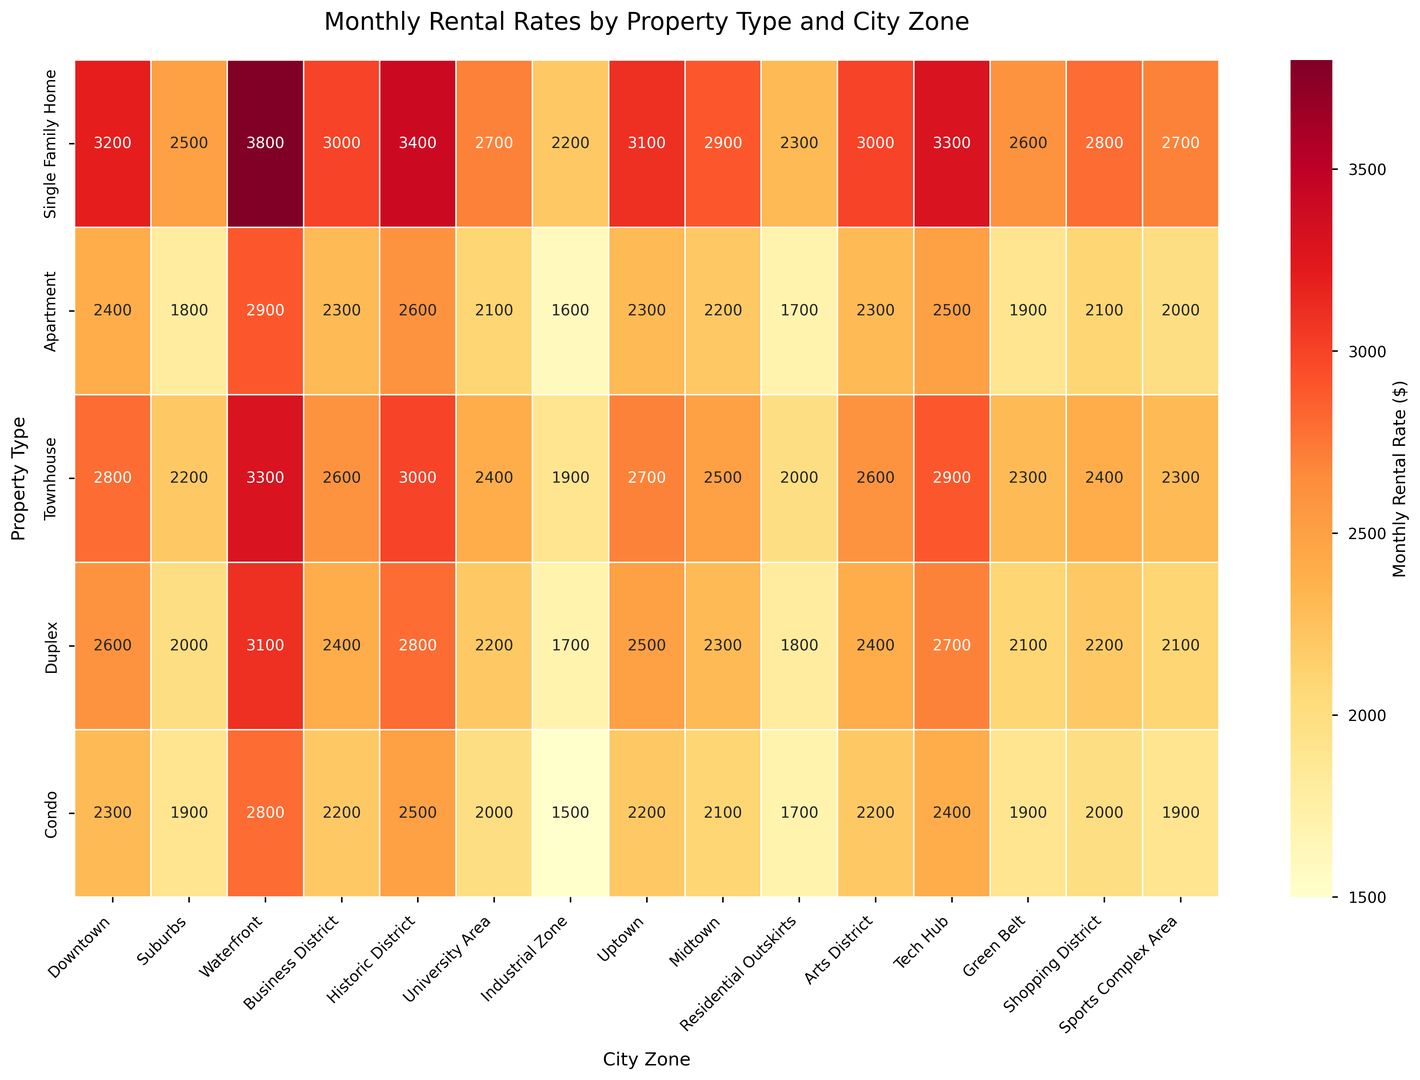What is the monthly rental rate for a Single Family Home in the Waterfront zone? By looking at the heatmap, find the intersection of the 'Single Family Home' row and the 'Waterfront' column.
Answer: 3800 Which city zone has the lowest rental rate for Apartments, and what is the value? Identify the minimum value in the 'Apartment' row and then find the corresponding city zone on the x-axis.
Answer: Industrial Zone, 1600 Out of Business District and University Area, which zone has higher average rental rates across all property types, and what are the averages? Calculate the average rental rates for both the Business District and University Area by summing the rates for all property types in each zone and then dividing by the number of property types (5). Business District: (3000 + 2300 + 2600 + 2400 + 2200) / 5 = 2500; University Area: (2700 + 2100 + 2400 + 2200 + 2000) / 5 = 2280. Compare the averages to determine which is higher.
Answer: Business District, 2500 Which property type has the most variability in rental rates across different city zones? To determine variability, compare the ranges (difference between the highest and lowest values) for each property type column.
Answer: Single Family Home (Highest value: 3800, Lowest value: 2200, Range: 3800-2200 = 1600) How many zones have a rental rate for Condos that is higher than $2200? Count the number of values in the 'Condo' row that are greater than 2200.
Answer: 5 (Downtown: 2300, Waterfront: 2800, Business District: 2200, Historic District: 2500, Tech Hub: 2400) What is the highest monthly rental rate for any property type in the entire set of city zones, and which zone and property type does it belong to? Locate the maximum value in the heatmap and check the corresponding row (property type) and column (city zone).
Answer: 3800, Waterfront, Single Family Home Comparing Townhouse and Duplex rental rates, in which zones do Townhouses have a higher rate than Duplexes, and by how much in each of those zones? Subtract the rental rate of Duplex from the rental rate of Townhouse in each zone and identify those with a positive difference. List the zones and the differences.
Answer: - Downtown: 2800 - 2600 = 200
  - Suburbs: 2200 - 2000 = 200
  - Waterfront: 3300 - 3100 = 200
  - Historic District: 3000 - 2800 = 200
  - Uptown: 2700 - 2500 = 200
  - Midtown: 2500 - 2300 = 200
  - Arts District: 2600 - 2400 = 200 What is the overall average monthly rental rate for the Green Belt zone across all property types? Calculate the average by summing the rental rates for all property types in the Green Belt zone and dividing by the number of property types (5). (2600 + 1900 + 2300 + 2100 + 1900) / 5 = 11600 / 5
Answer: 2320 